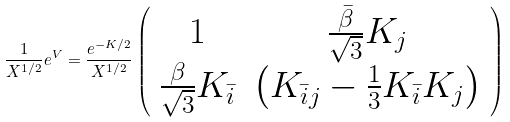<formula> <loc_0><loc_0><loc_500><loc_500>\frac { 1 } { X ^ { 1 / 2 } } e ^ { V } = \frac { e ^ { - K / 2 } } { X ^ { 1 / 2 } } \left ( \begin{array} { c c } 1 & \frac { \bar { \beta } } { \sqrt { 3 } } K _ { j } \\ \frac { \beta } { \sqrt { 3 } } K _ { \bar { i } } & \left ( K _ { \bar { i } j } - \frac { 1 } { 3 } K _ { \bar { i } } K _ { j } \right ) \end{array} \right )</formula> 